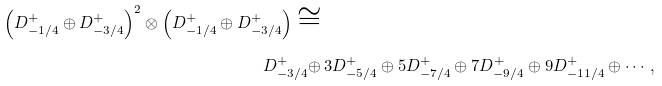Convert formula to latex. <formula><loc_0><loc_0><loc_500><loc_500>\left ( D ^ { + } _ { - 1 / 4 } \oplus D ^ { + } _ { - 3 / 4 } \right ) ^ { 2 } \otimes \left ( D ^ { + } _ { - 1 / 4 } \oplus D ^ { + } _ { - 3 / 4 } \right ) \cong & \, \\ D ^ { + } _ { - 3 / 4 } \oplus & \, 3 D ^ { + } _ { - 5 / 4 } \oplus 5 D ^ { + } _ { - 7 / 4 } \oplus 7 D ^ { + } _ { - 9 / 4 } \oplus 9 D ^ { + } _ { - 1 1 / 4 } \oplus \cdots ,</formula> 